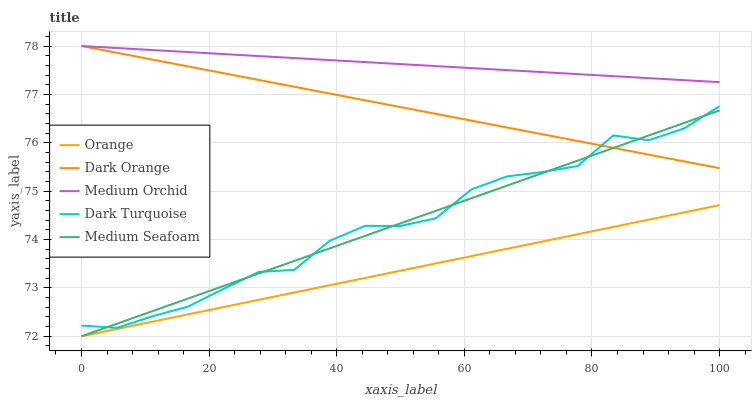Does Orange have the minimum area under the curve?
Answer yes or no. Yes. Does Medium Orchid have the maximum area under the curve?
Answer yes or no. Yes. Does Dark Orange have the minimum area under the curve?
Answer yes or no. No. Does Dark Orange have the maximum area under the curve?
Answer yes or no. No. Is Medium Orchid the smoothest?
Answer yes or no. Yes. Is Dark Turquoise the roughest?
Answer yes or no. Yes. Is Dark Orange the smoothest?
Answer yes or no. No. Is Dark Orange the roughest?
Answer yes or no. No. Does Orange have the lowest value?
Answer yes or no. Yes. Does Dark Orange have the lowest value?
Answer yes or no. No. Does Medium Orchid have the highest value?
Answer yes or no. Yes. Does Medium Seafoam have the highest value?
Answer yes or no. No. Is Orange less than Medium Orchid?
Answer yes or no. Yes. Is Medium Orchid greater than Medium Seafoam?
Answer yes or no. Yes. Does Dark Orange intersect Medium Orchid?
Answer yes or no. Yes. Is Dark Orange less than Medium Orchid?
Answer yes or no. No. Is Dark Orange greater than Medium Orchid?
Answer yes or no. No. Does Orange intersect Medium Orchid?
Answer yes or no. No. 